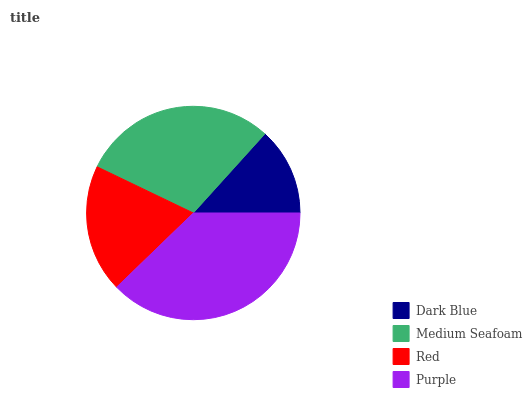Is Dark Blue the minimum?
Answer yes or no. Yes. Is Purple the maximum?
Answer yes or no. Yes. Is Medium Seafoam the minimum?
Answer yes or no. No. Is Medium Seafoam the maximum?
Answer yes or no. No. Is Medium Seafoam greater than Dark Blue?
Answer yes or no. Yes. Is Dark Blue less than Medium Seafoam?
Answer yes or no. Yes. Is Dark Blue greater than Medium Seafoam?
Answer yes or no. No. Is Medium Seafoam less than Dark Blue?
Answer yes or no. No. Is Medium Seafoam the high median?
Answer yes or no. Yes. Is Red the low median?
Answer yes or no. Yes. Is Red the high median?
Answer yes or no. No. Is Dark Blue the low median?
Answer yes or no. No. 